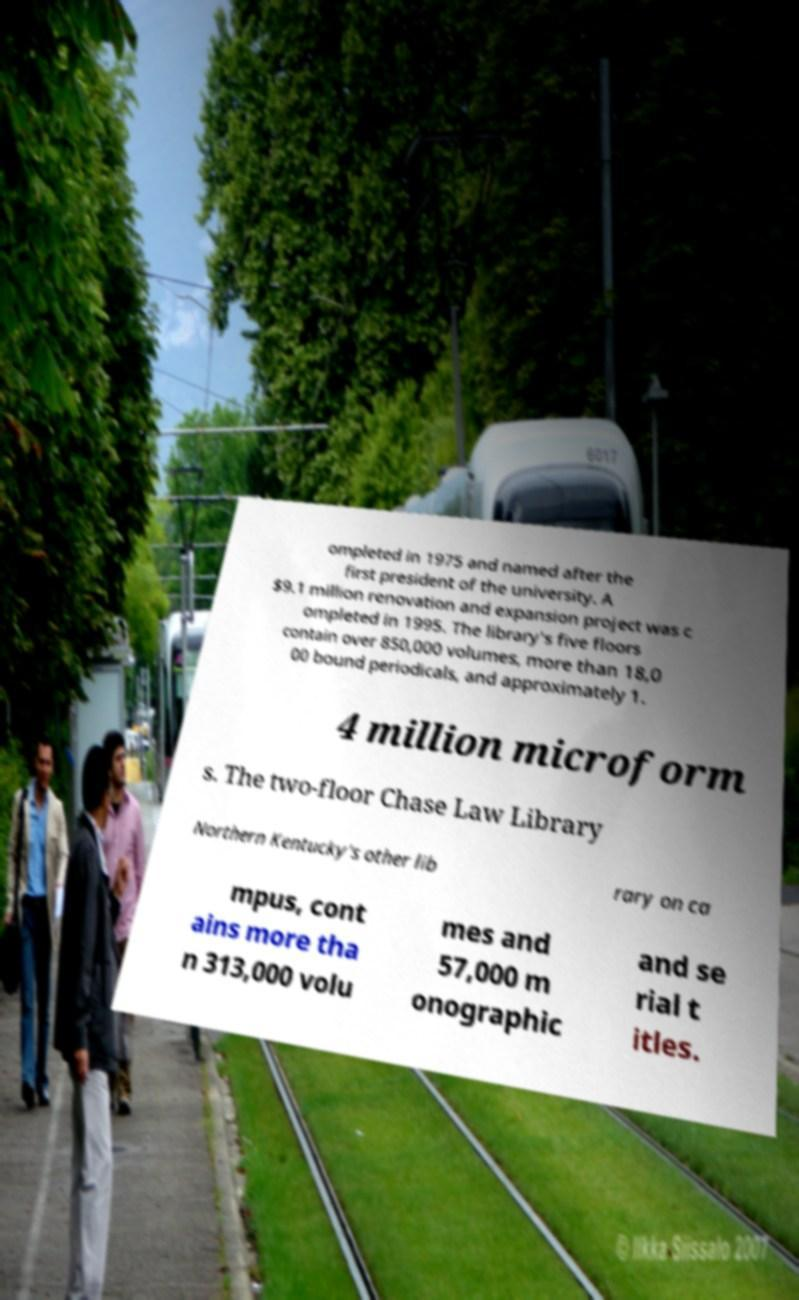For documentation purposes, I need the text within this image transcribed. Could you provide that? ompleted in 1975 and named after the first president of the university. A $9.1 million renovation and expansion project was c ompleted in 1995. The library's five floors contain over 850,000 volumes, more than 18,0 00 bound periodicals, and approximately 1. 4 million microform s. The two-floor Chase Law Library Northern Kentucky's other lib rary on ca mpus, cont ains more tha n 313,000 volu mes and 57,000 m onographic and se rial t itles. 